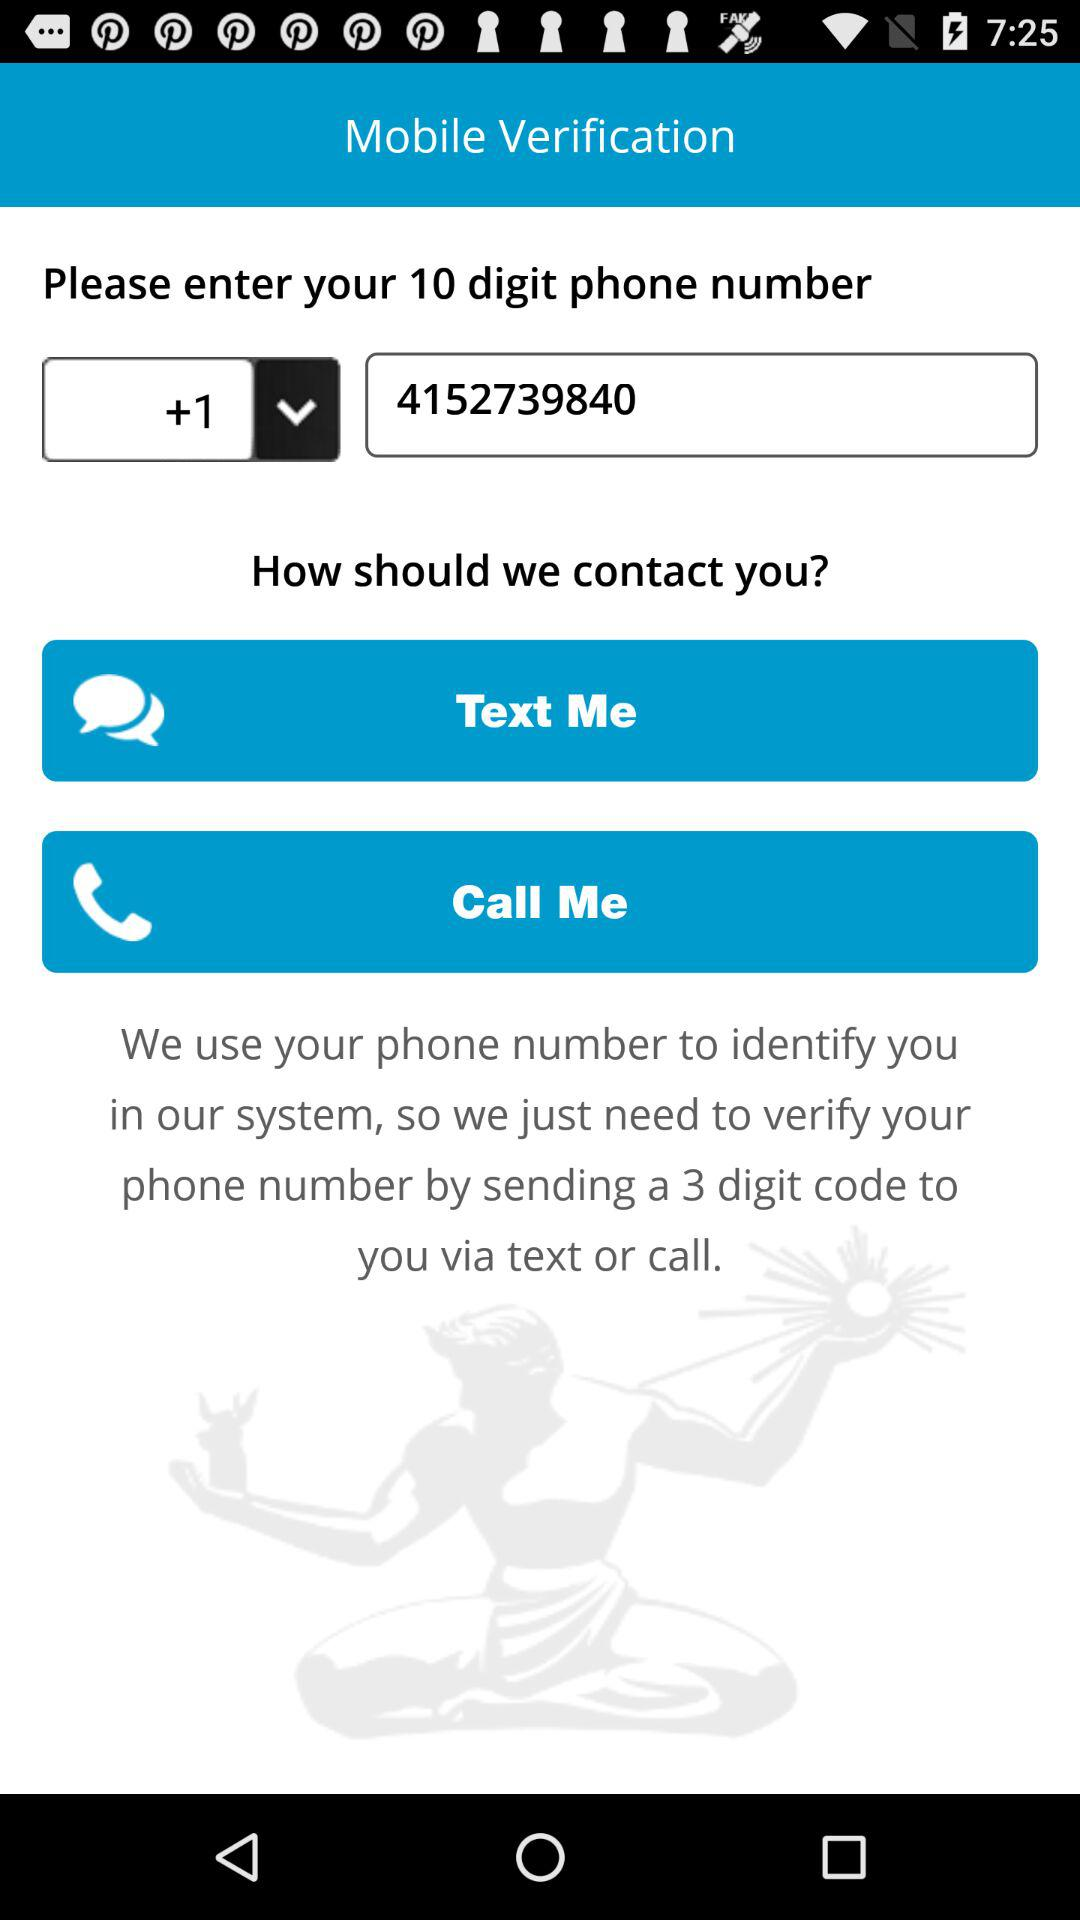What are the options I can select for the verification through my phone number? The options you can select for the verification through your phone number are: Text and Call. 